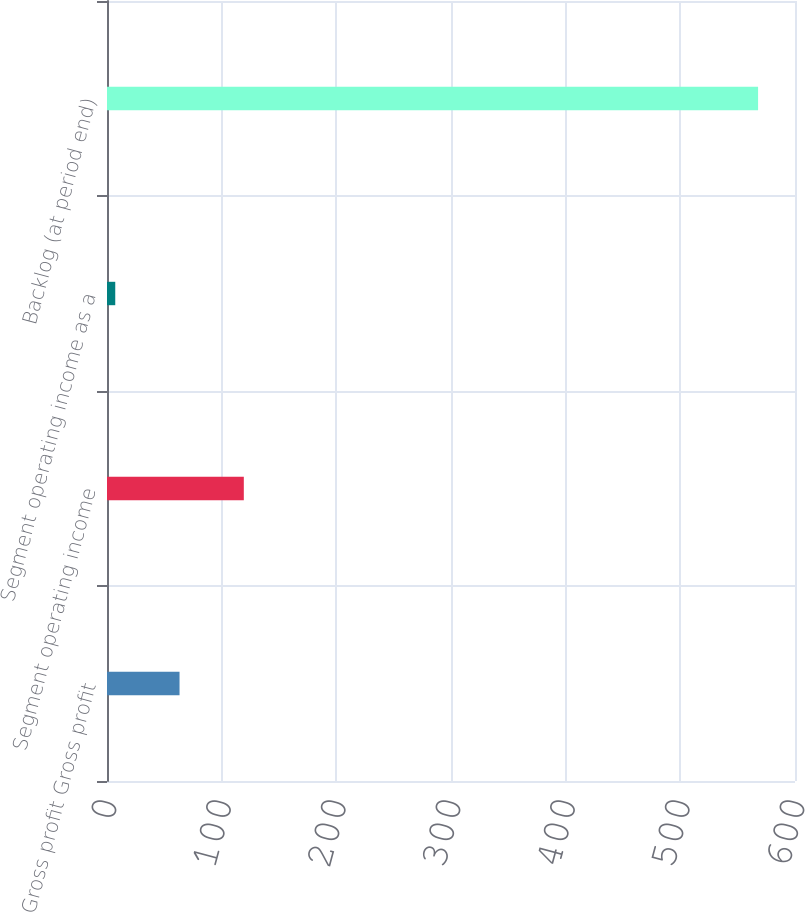Convert chart to OTSL. <chart><loc_0><loc_0><loc_500><loc_500><bar_chart><fcel>Gross profit Gross profit<fcel>Segment operating income<fcel>Segment operating income as a<fcel>Backlog (at period end)<nl><fcel>63.26<fcel>119.32<fcel>7.2<fcel>567.8<nl></chart> 